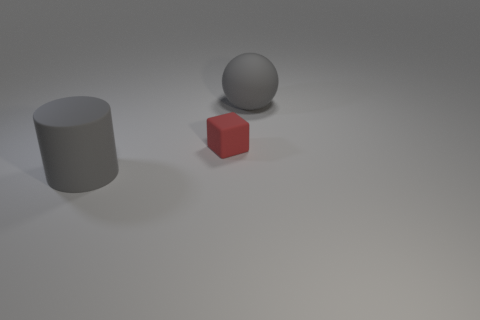Add 2 green matte blocks. How many objects exist? 5 Subtract 0 gray cubes. How many objects are left? 3 Subtract all cylinders. How many objects are left? 2 Subtract all cyan balls. Subtract all brown blocks. How many balls are left? 1 Subtract all gray rubber cylinders. Subtract all large objects. How many objects are left? 0 Add 3 big gray cylinders. How many big gray cylinders are left? 4 Add 2 tiny gray balls. How many tiny gray balls exist? 2 